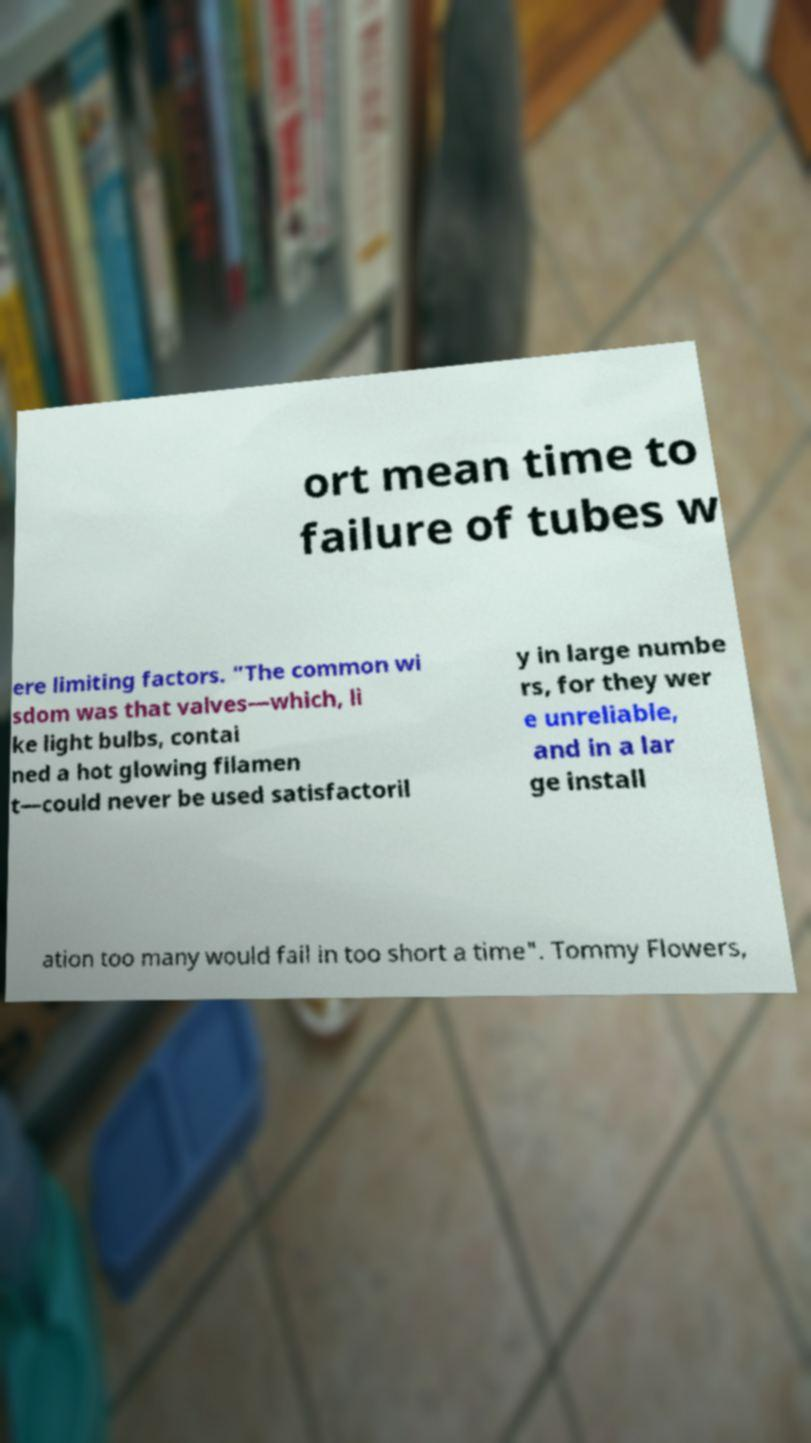Could you assist in decoding the text presented in this image and type it out clearly? ort mean time to failure of tubes w ere limiting factors. "The common wi sdom was that valves—which, li ke light bulbs, contai ned a hot glowing filamen t—could never be used satisfactoril y in large numbe rs, for they wer e unreliable, and in a lar ge install ation too many would fail in too short a time". Tommy Flowers, 